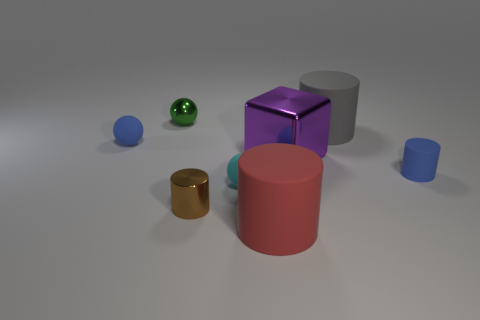There is a blue matte sphere; is it the same size as the blue object on the right side of the tiny blue matte sphere?
Your answer should be compact. Yes. Are there any blue matte spheres that have the same size as the red matte thing?
Provide a short and direct response. No. What number of other objects are the same material as the blue sphere?
Ensure brevity in your answer.  4. The metallic thing that is both left of the purple shiny thing and in front of the tiny metallic ball is what color?
Give a very brief answer. Brown. Do the small blue object that is to the left of the red object and the small blue object on the right side of the metallic ball have the same material?
Your answer should be very brief. Yes. Do the red object to the left of the block and the purple metal block have the same size?
Your response must be concise. Yes. Does the small matte cylinder have the same color as the matte object that is to the left of the green shiny thing?
Ensure brevity in your answer.  Yes. What shape is the small matte object that is the same color as the tiny matte cylinder?
Offer a terse response. Sphere. What is the shape of the brown metal thing?
Offer a very short reply. Cylinder. What number of things are gray rubber things that are to the right of the tiny green shiny ball or large things?
Your answer should be very brief. 3. 